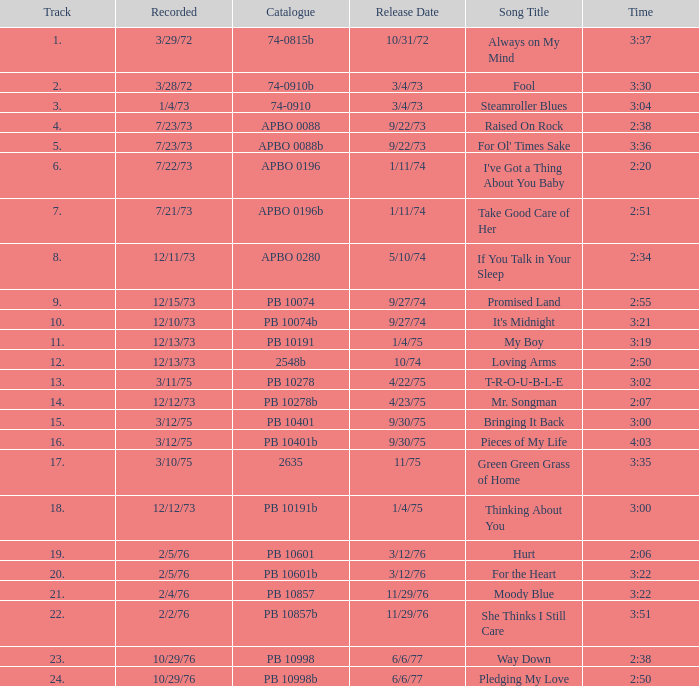Give me the registered time of 2:50 and the publication date of 6/6/77 with a track quantity of more than 2 10/29/76. 